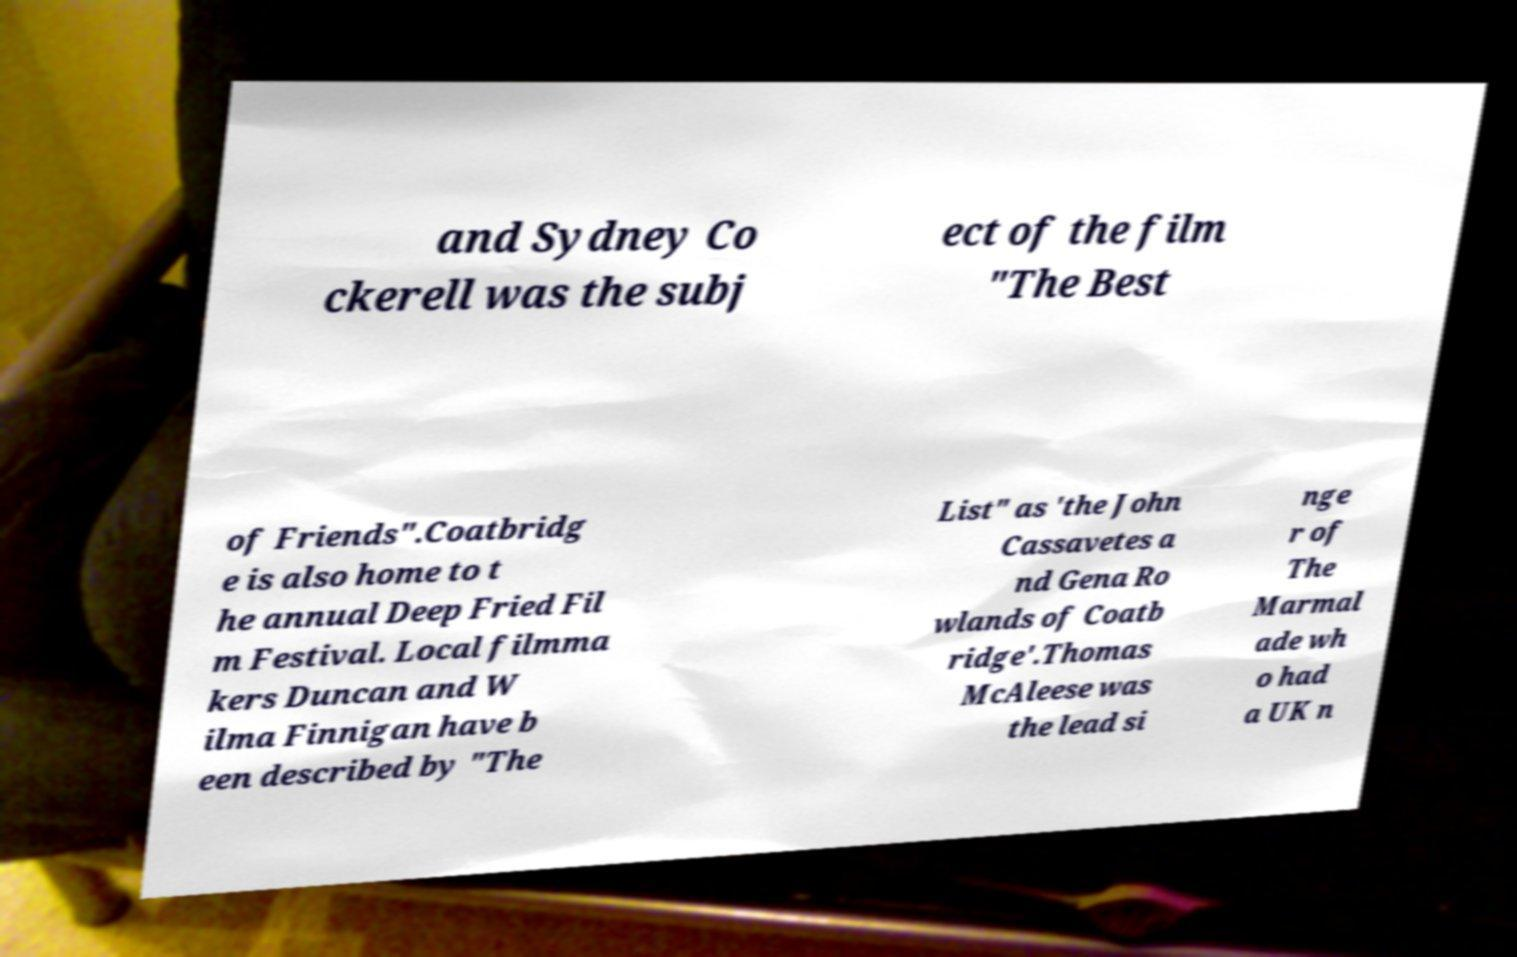Could you assist in decoding the text presented in this image and type it out clearly? and Sydney Co ckerell was the subj ect of the film "The Best of Friends".Coatbridg e is also home to t he annual Deep Fried Fil m Festival. Local filmma kers Duncan and W ilma Finnigan have b een described by "The List" as 'the John Cassavetes a nd Gena Ro wlands of Coatb ridge'.Thomas McAleese was the lead si nge r of The Marmal ade wh o had a UK n 